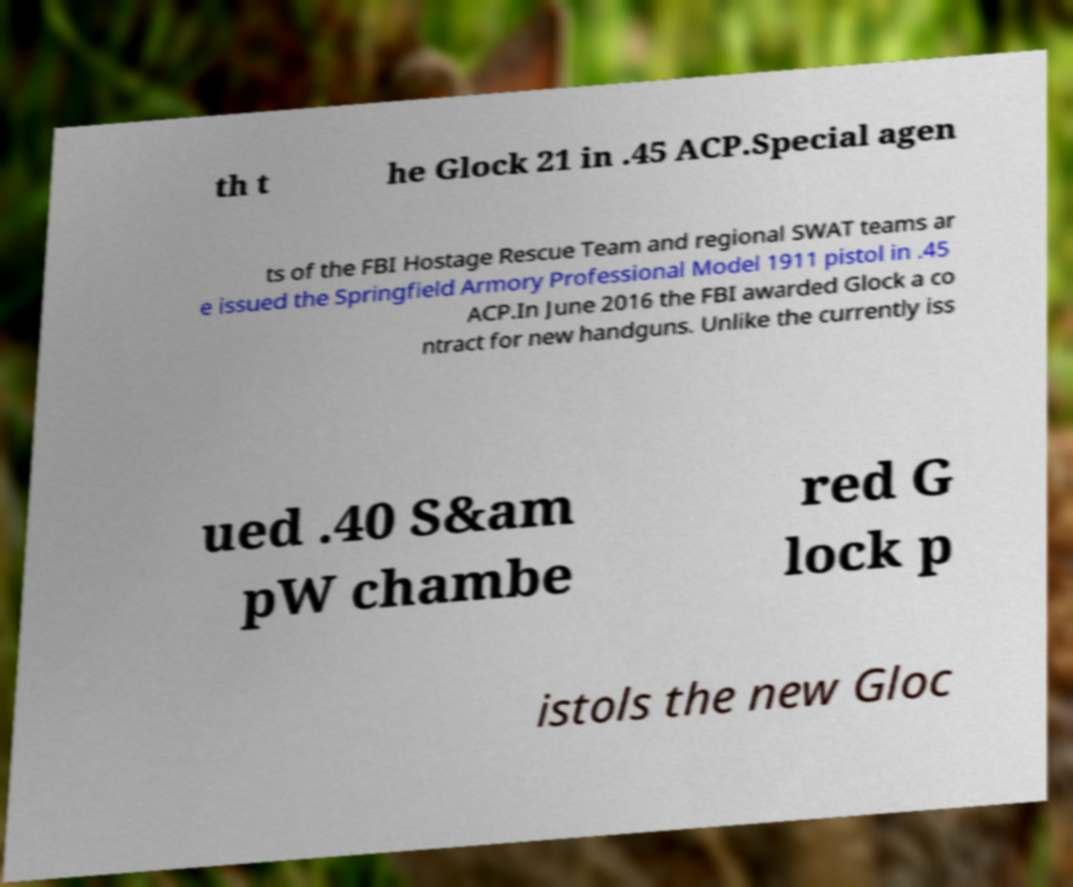Could you assist in decoding the text presented in this image and type it out clearly? th t he Glock 21 in .45 ACP.Special agen ts of the FBI Hostage Rescue Team and regional SWAT teams ar e issued the Springfield Armory Professional Model 1911 pistol in .45 ACP.In June 2016 the FBI awarded Glock a co ntract for new handguns. Unlike the currently iss ued .40 S&am pW chambe red G lock p istols the new Gloc 